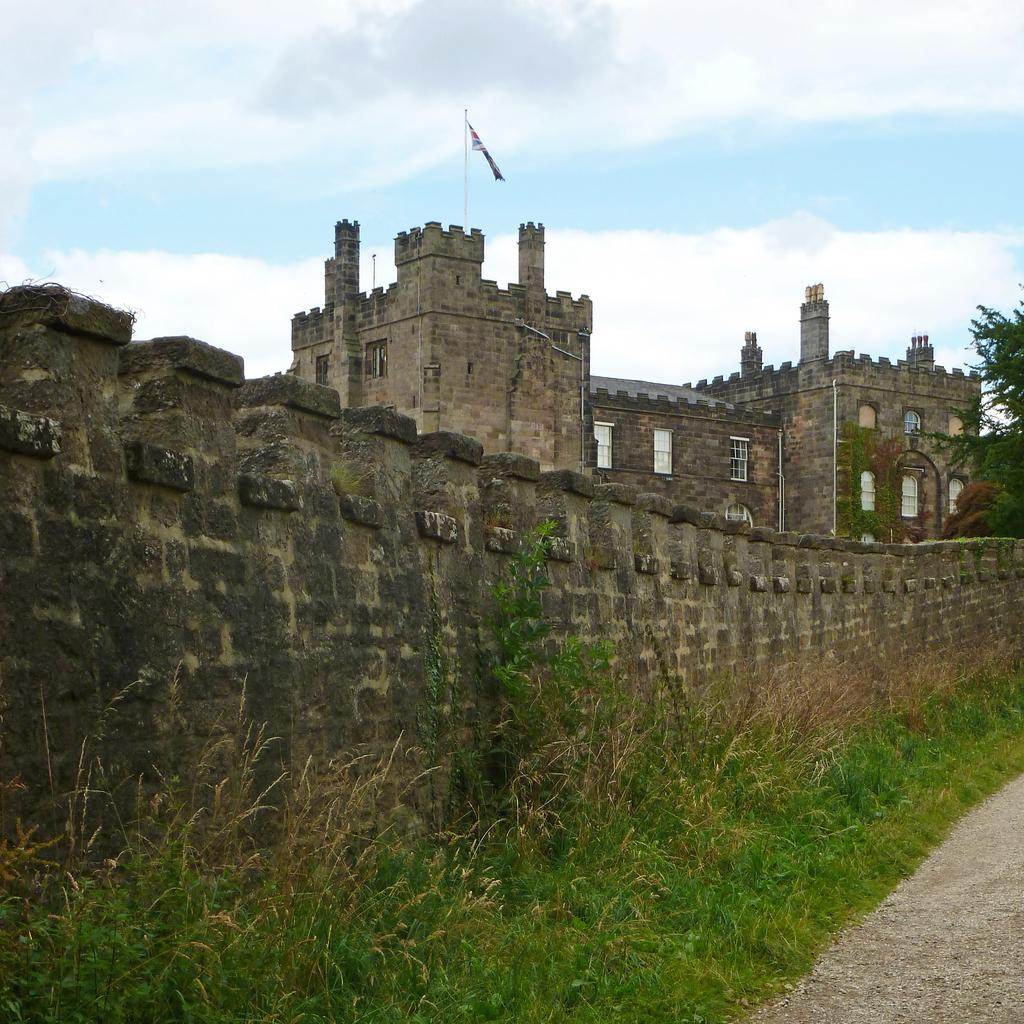What can be seen at the top of the image? The sky with clouds is visible at the top of the image. What is on top of the building in the image? There is a flag on top of the building. What type of vegetation is near the wall in the image? Grass is present near a wall. What type of pathway is visible in the image? A road is visible in the image. What type of sponge is being used to clean the flag in the image? There is no sponge present in the image, and the flag is not being cleaned. What color is the sweater worn by the person near the wall in the image? There are no people visible in the image, so it is impossible to determine the color of any sweater. 